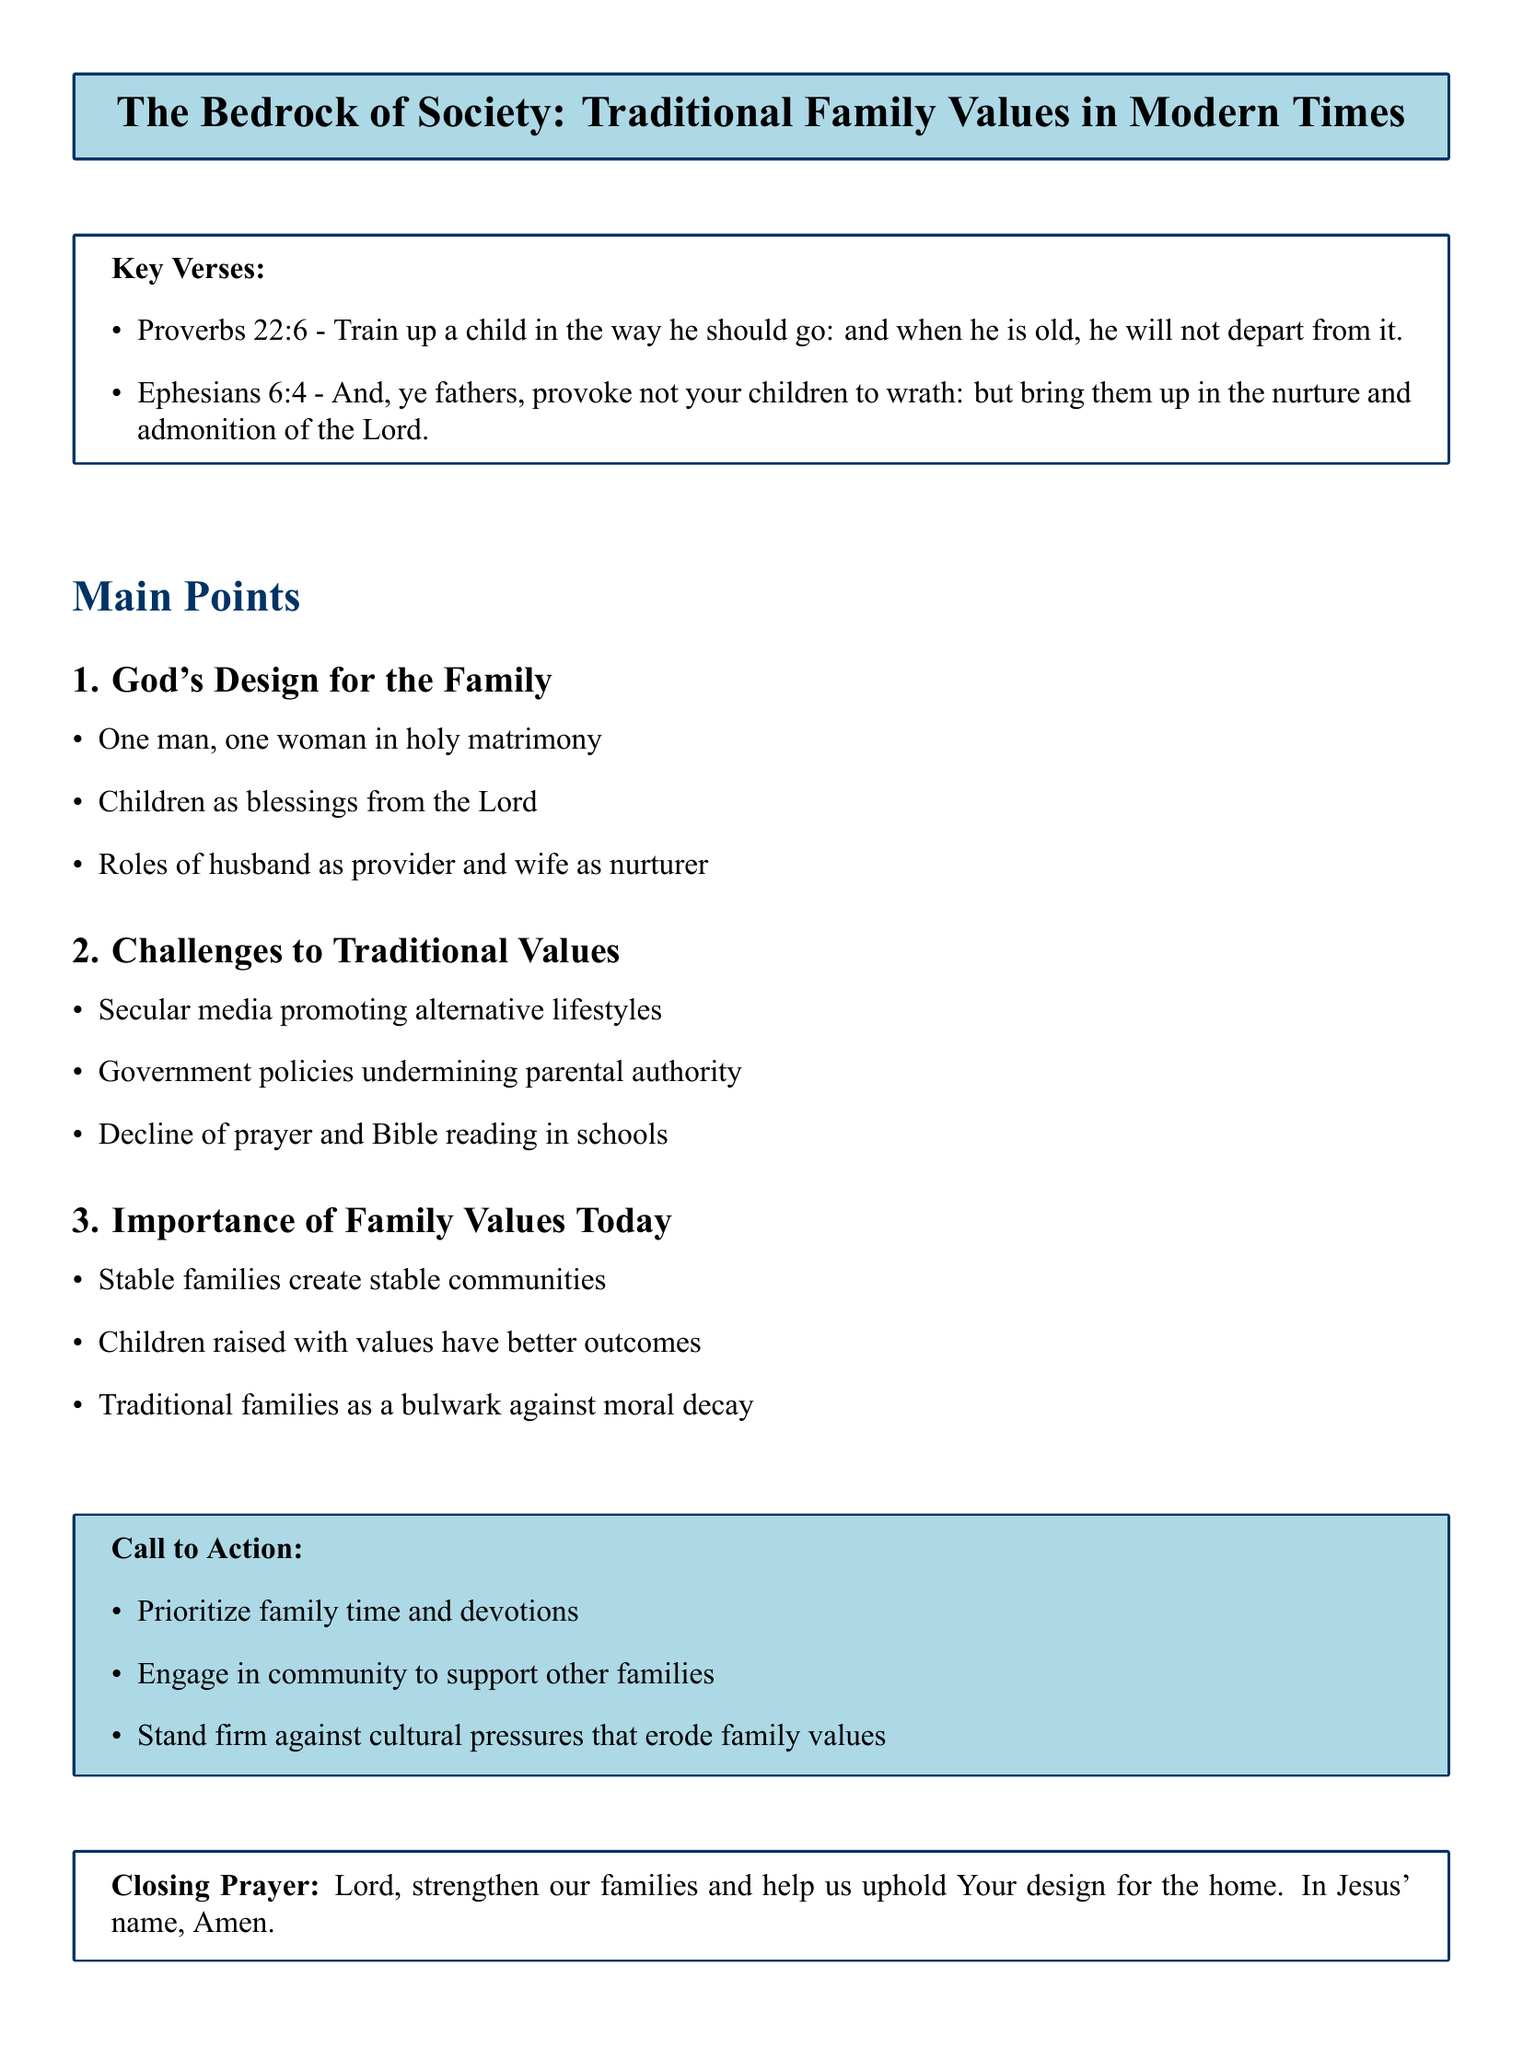What is the title of the document? The title appears at the beginning of the document in a box, summarizing the main theme.
Answer: The Bedrock of Society: Traditional Family Values in Modern Times What are the key verses highlighted in the document? The key verses provide biblical support for the main points discussed.
Answer: Proverbs 22:6 and Ephesians 6:4 How many main points are discussed in the document? The document outlines three main points under the section "Main Points."
Answer: 3 What is the first detail under God's Design for the Family? The details provide insight into the traditional family structure emphasized in the document.
Answer: One man, one woman in holy matrimony What challenge to traditional values is mentioned regarding schools? This challenge highlights a decline in religious practices within the educational system.
Answer: Decline of prayer and Bible reading in schools What is one of the call to action items suggested in the document? The call to action encourages specific behaviors to uphold family values.
Answer: Prioritize family time and devotions What role is designated for the husband in traditional family values? This detail emphasizes the specific responsibilities assigned to family members within traditional values.
Answer: Provider What is the closing prayer's main request? The closing prayer summarizes the hope for family support within the community.
Answer: Strengthen our families What phrase describes the hope for families raised with traditional values? This phrase indicates the expected outcomes of following traditional family values.
Answer: Better outcomes 